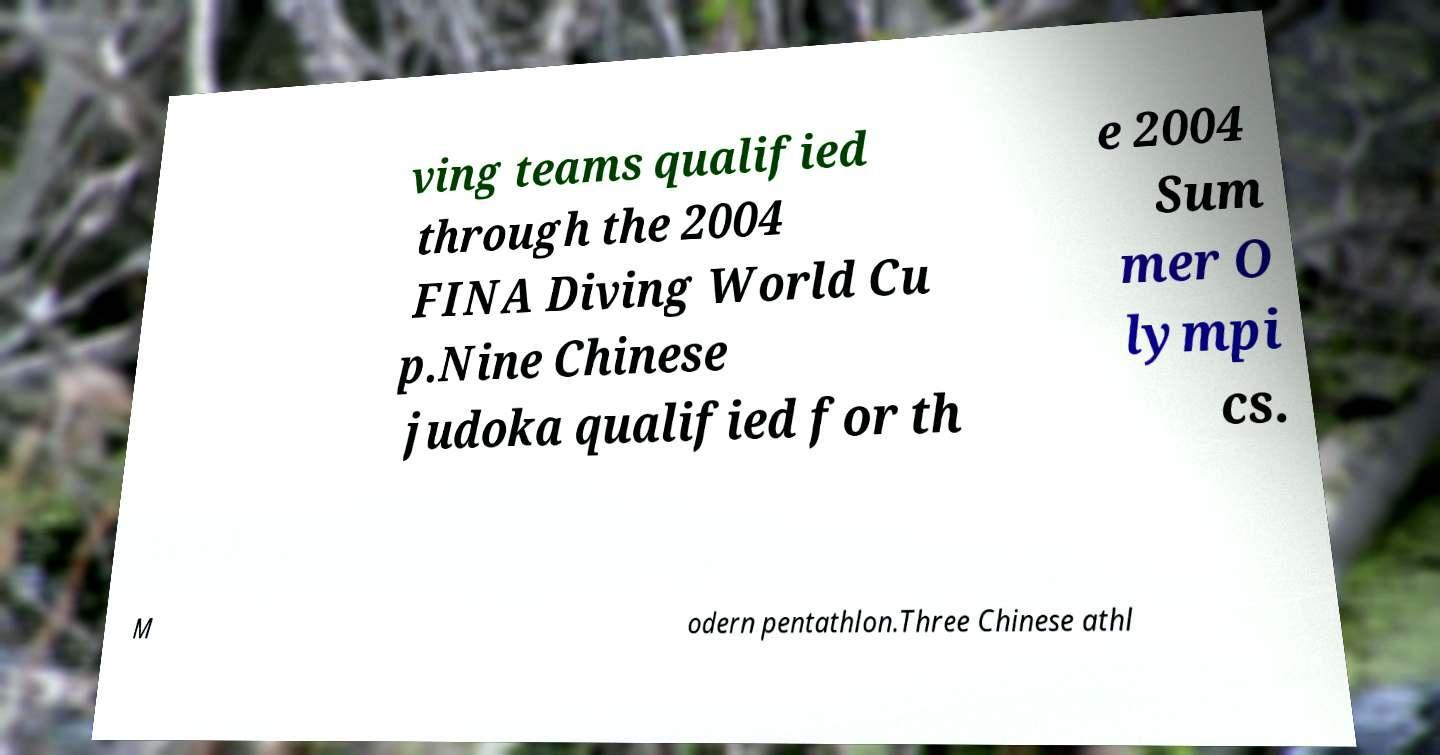Can you accurately transcribe the text from the provided image for me? ving teams qualified through the 2004 FINA Diving World Cu p.Nine Chinese judoka qualified for th e 2004 Sum mer O lympi cs. M odern pentathlon.Three Chinese athl 